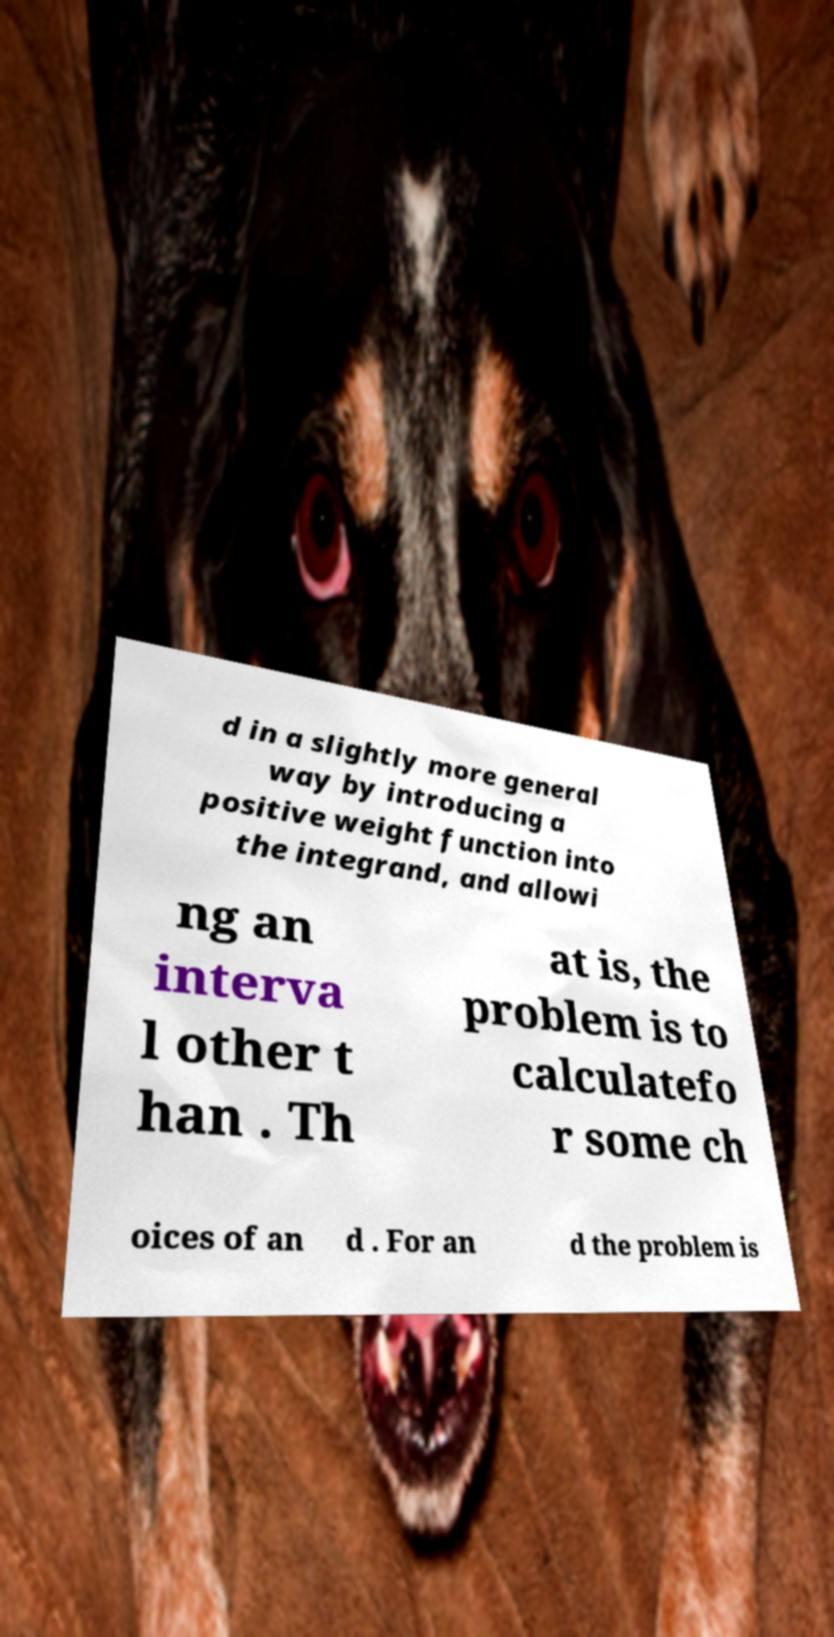Could you assist in decoding the text presented in this image and type it out clearly? d in a slightly more general way by introducing a positive weight function into the integrand, and allowi ng an interva l other t han . Th at is, the problem is to calculatefo r some ch oices of an d . For an d the problem is 